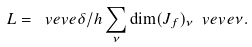<formula> <loc_0><loc_0><loc_500><loc_500>L = \ v e v { e { \delta / h } } \sum _ { \nu } \dim ( J _ { f } ) _ { \nu } \ v e v { e { \nu } } .</formula> 